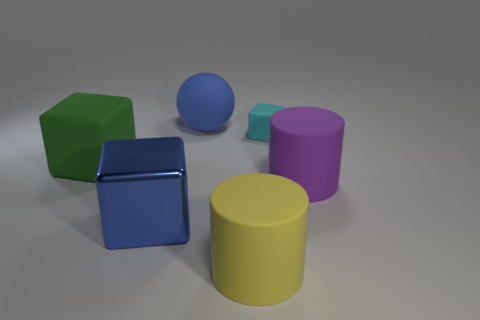What number of yellow cylinders are left of the matte thing that is on the left side of the blue object behind the metal block? 0 